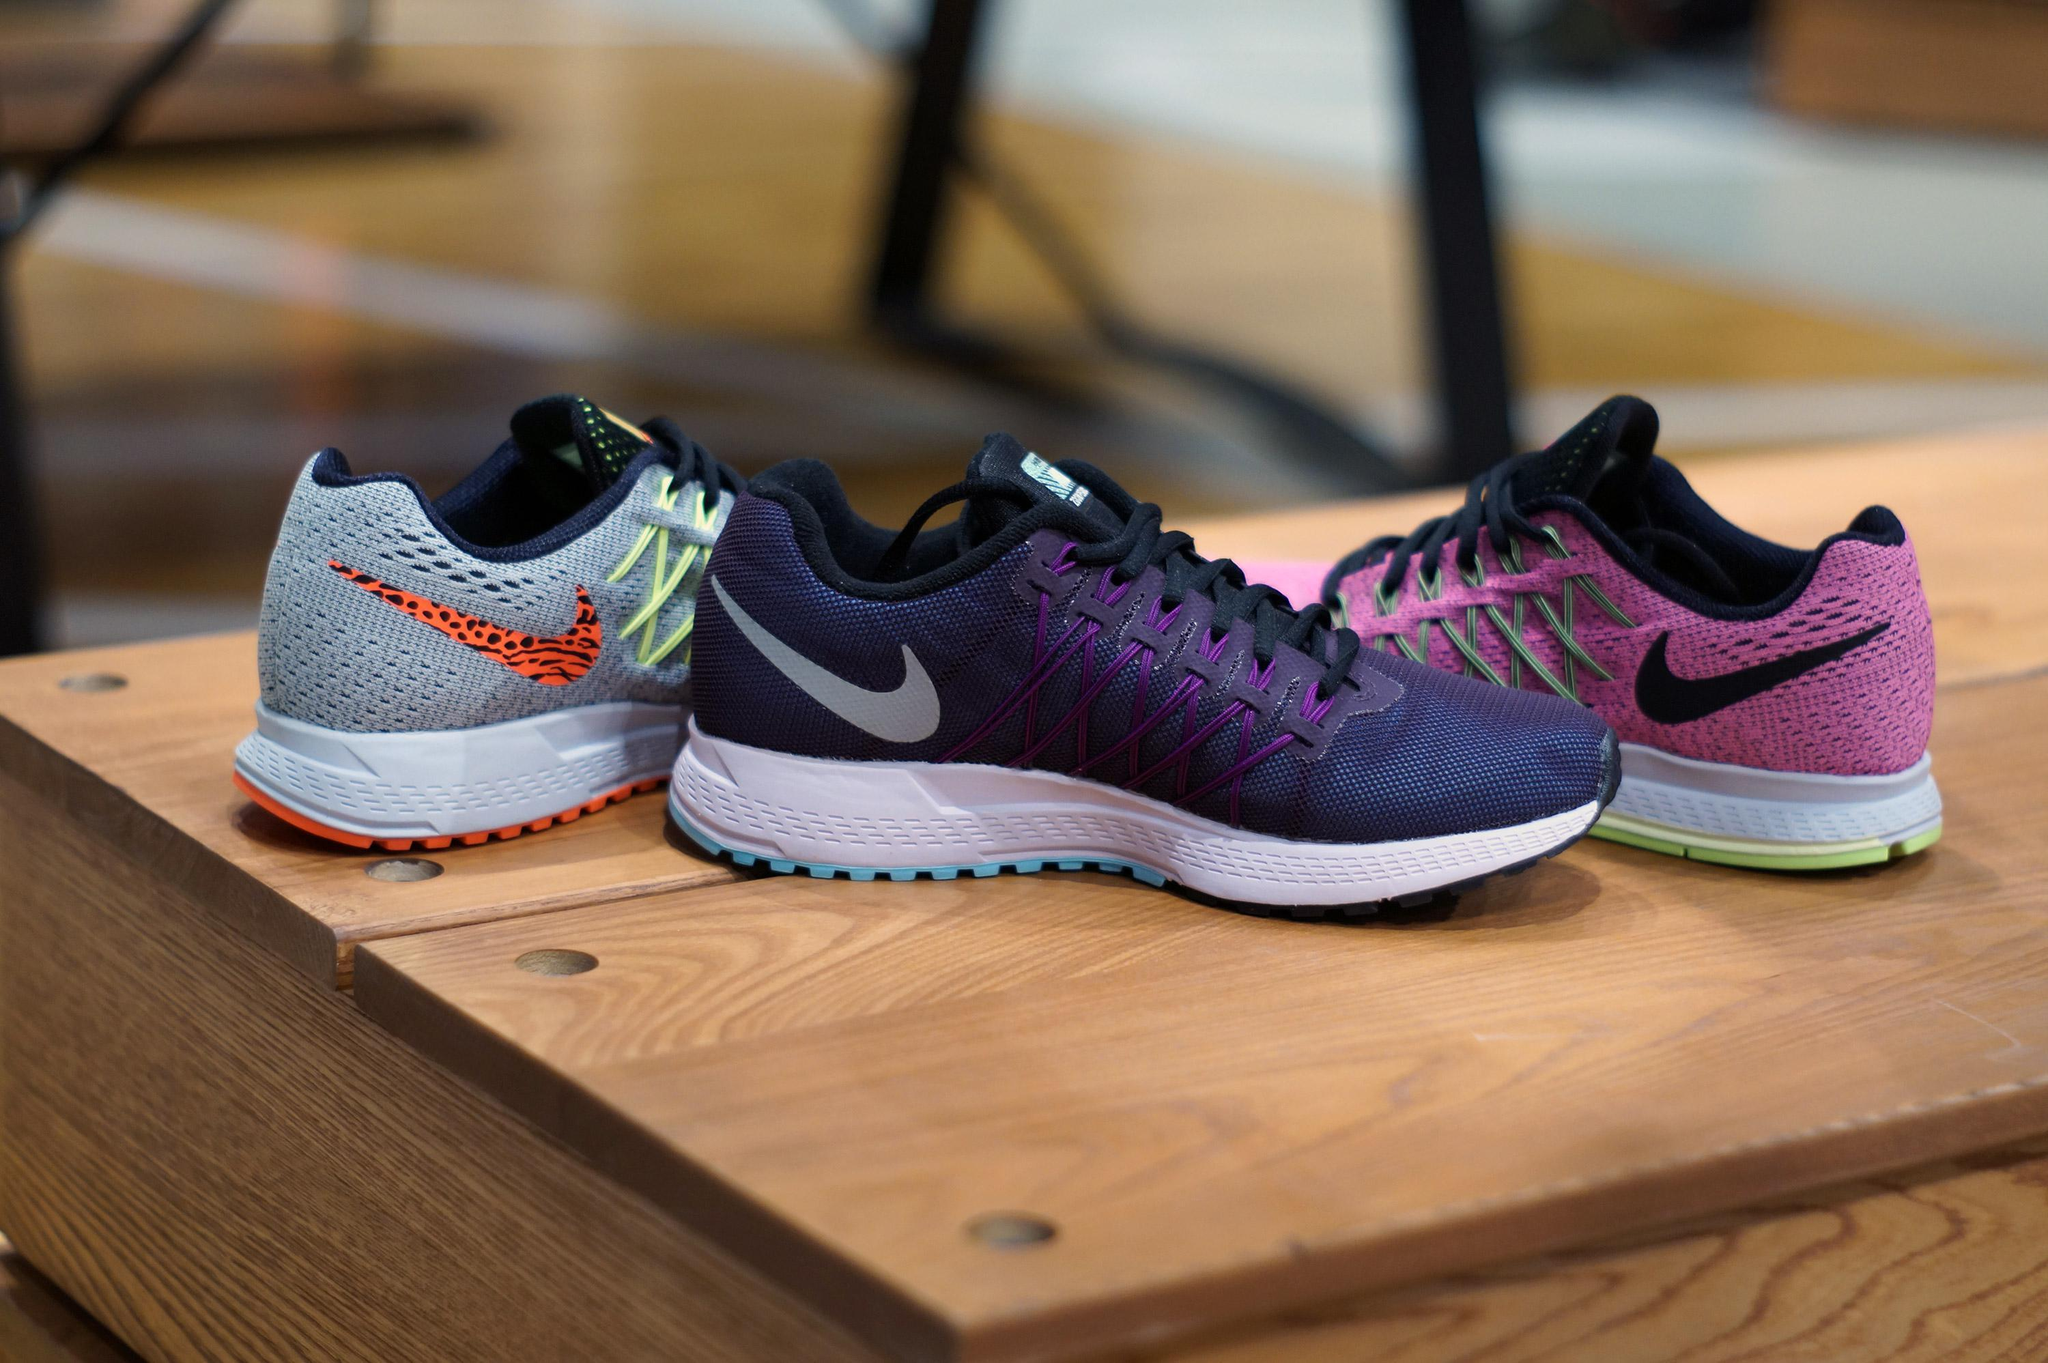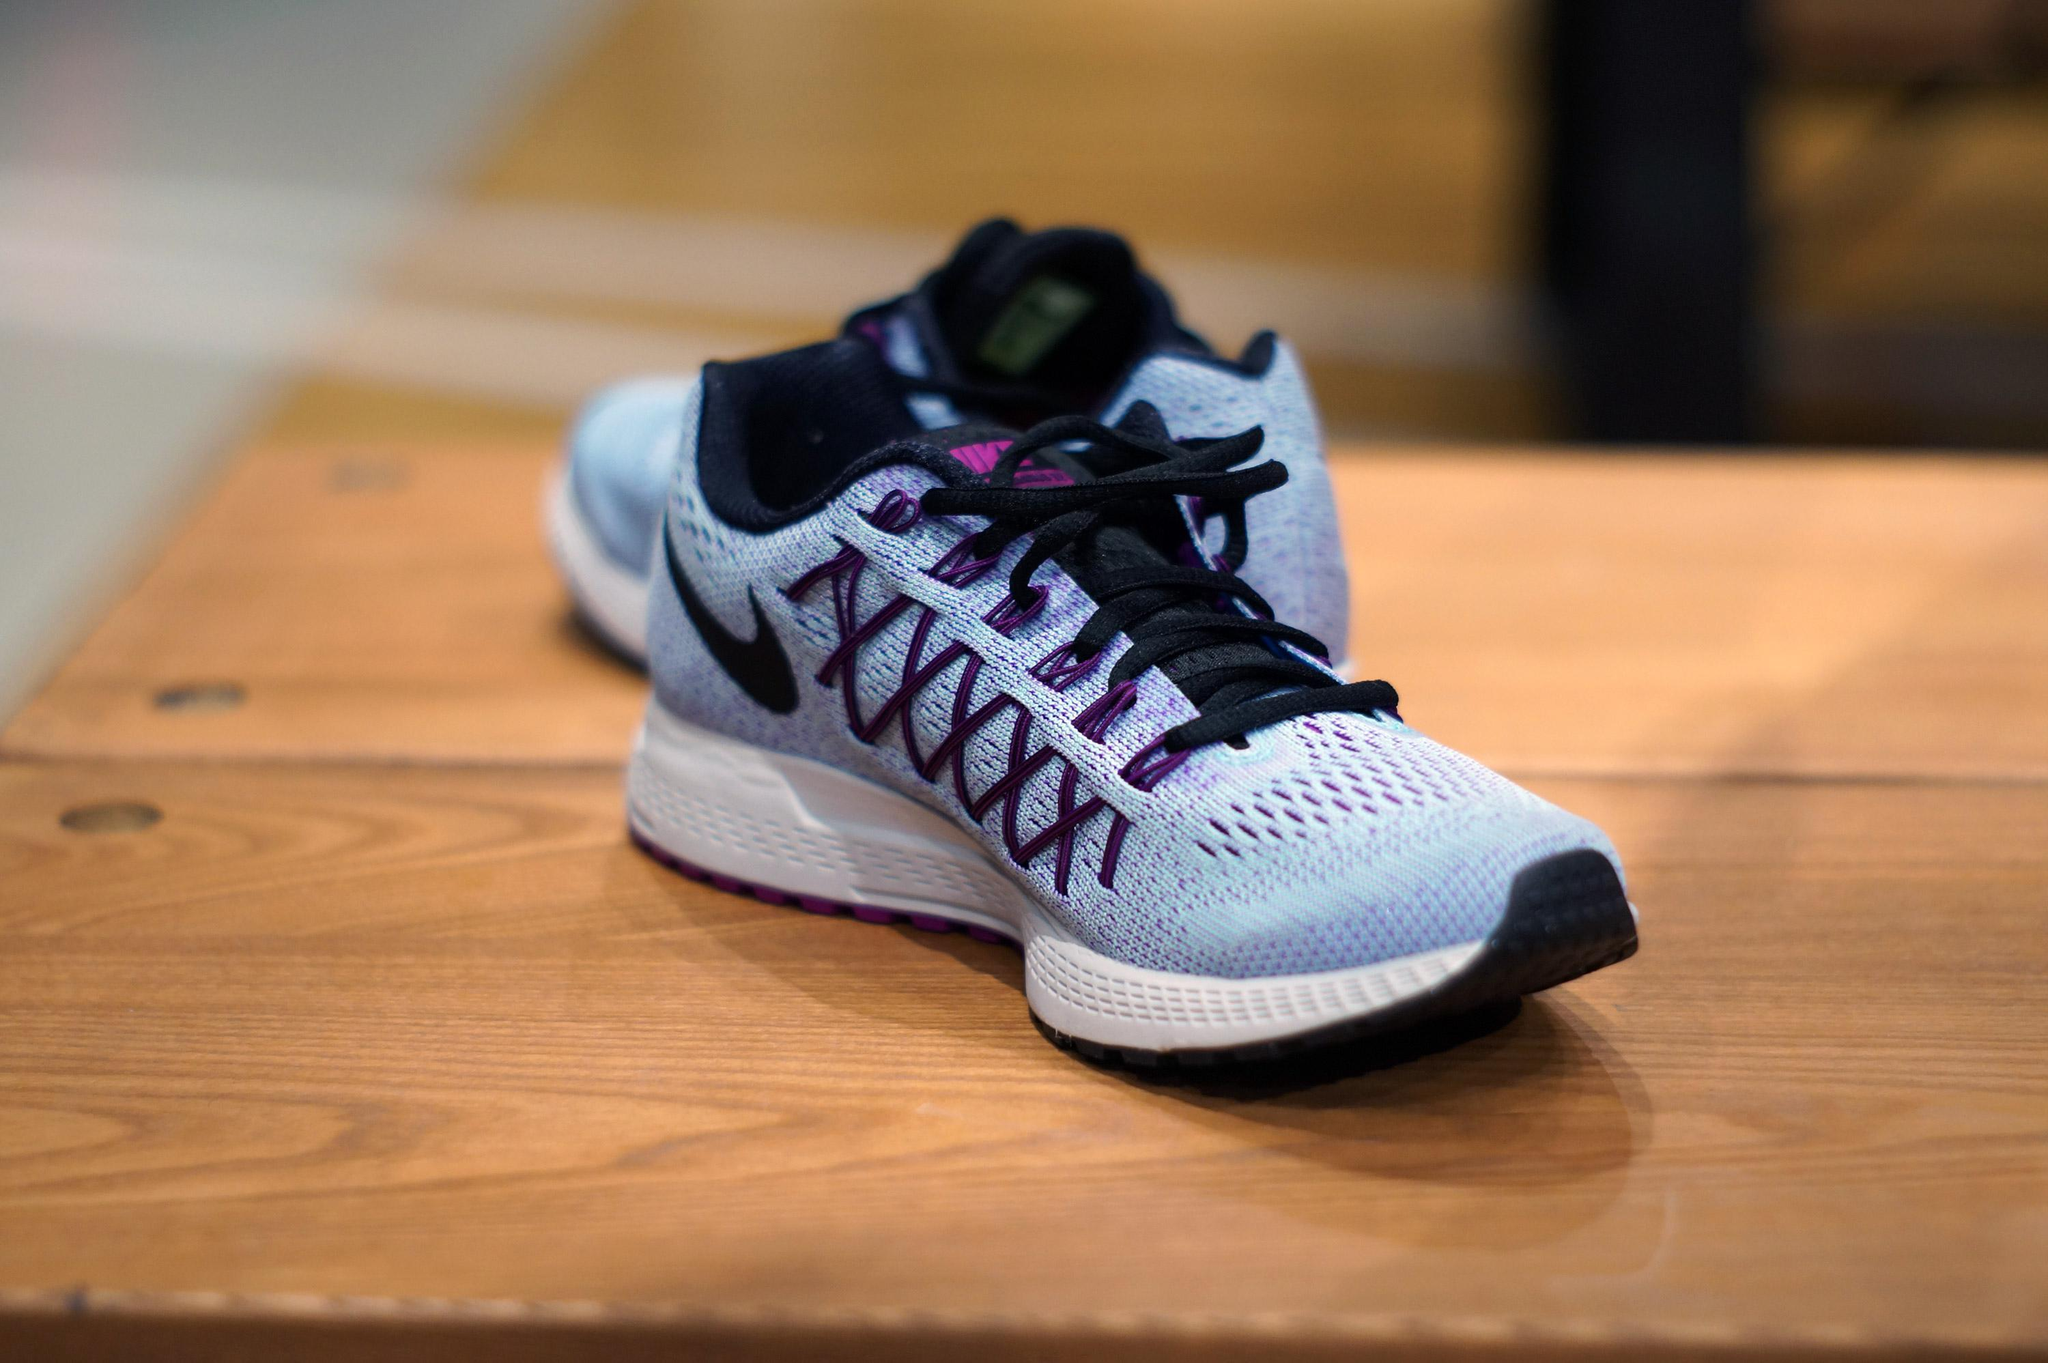The first image is the image on the left, the second image is the image on the right. Assess this claim about the two images: "A total of three shoes are shown.". Correct or not? Answer yes or no. No. 